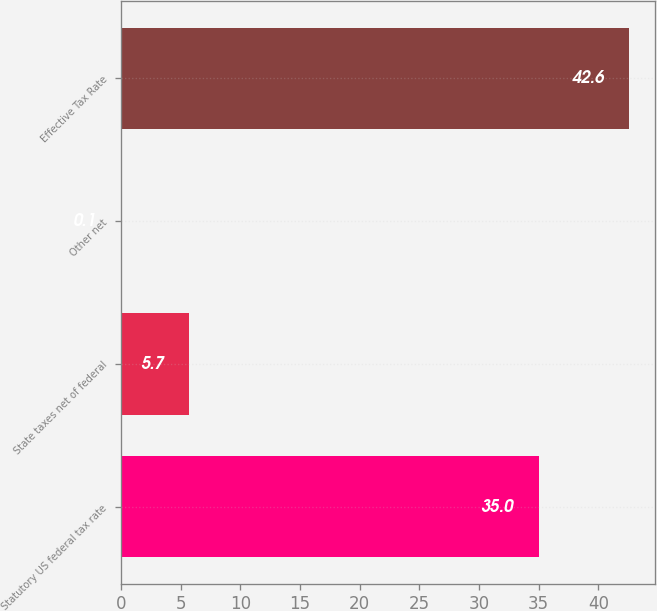<chart> <loc_0><loc_0><loc_500><loc_500><bar_chart><fcel>Statutory US federal tax rate<fcel>State taxes net of federal<fcel>Other net<fcel>Effective Tax Rate<nl><fcel>35<fcel>5.7<fcel>0.1<fcel>42.6<nl></chart> 